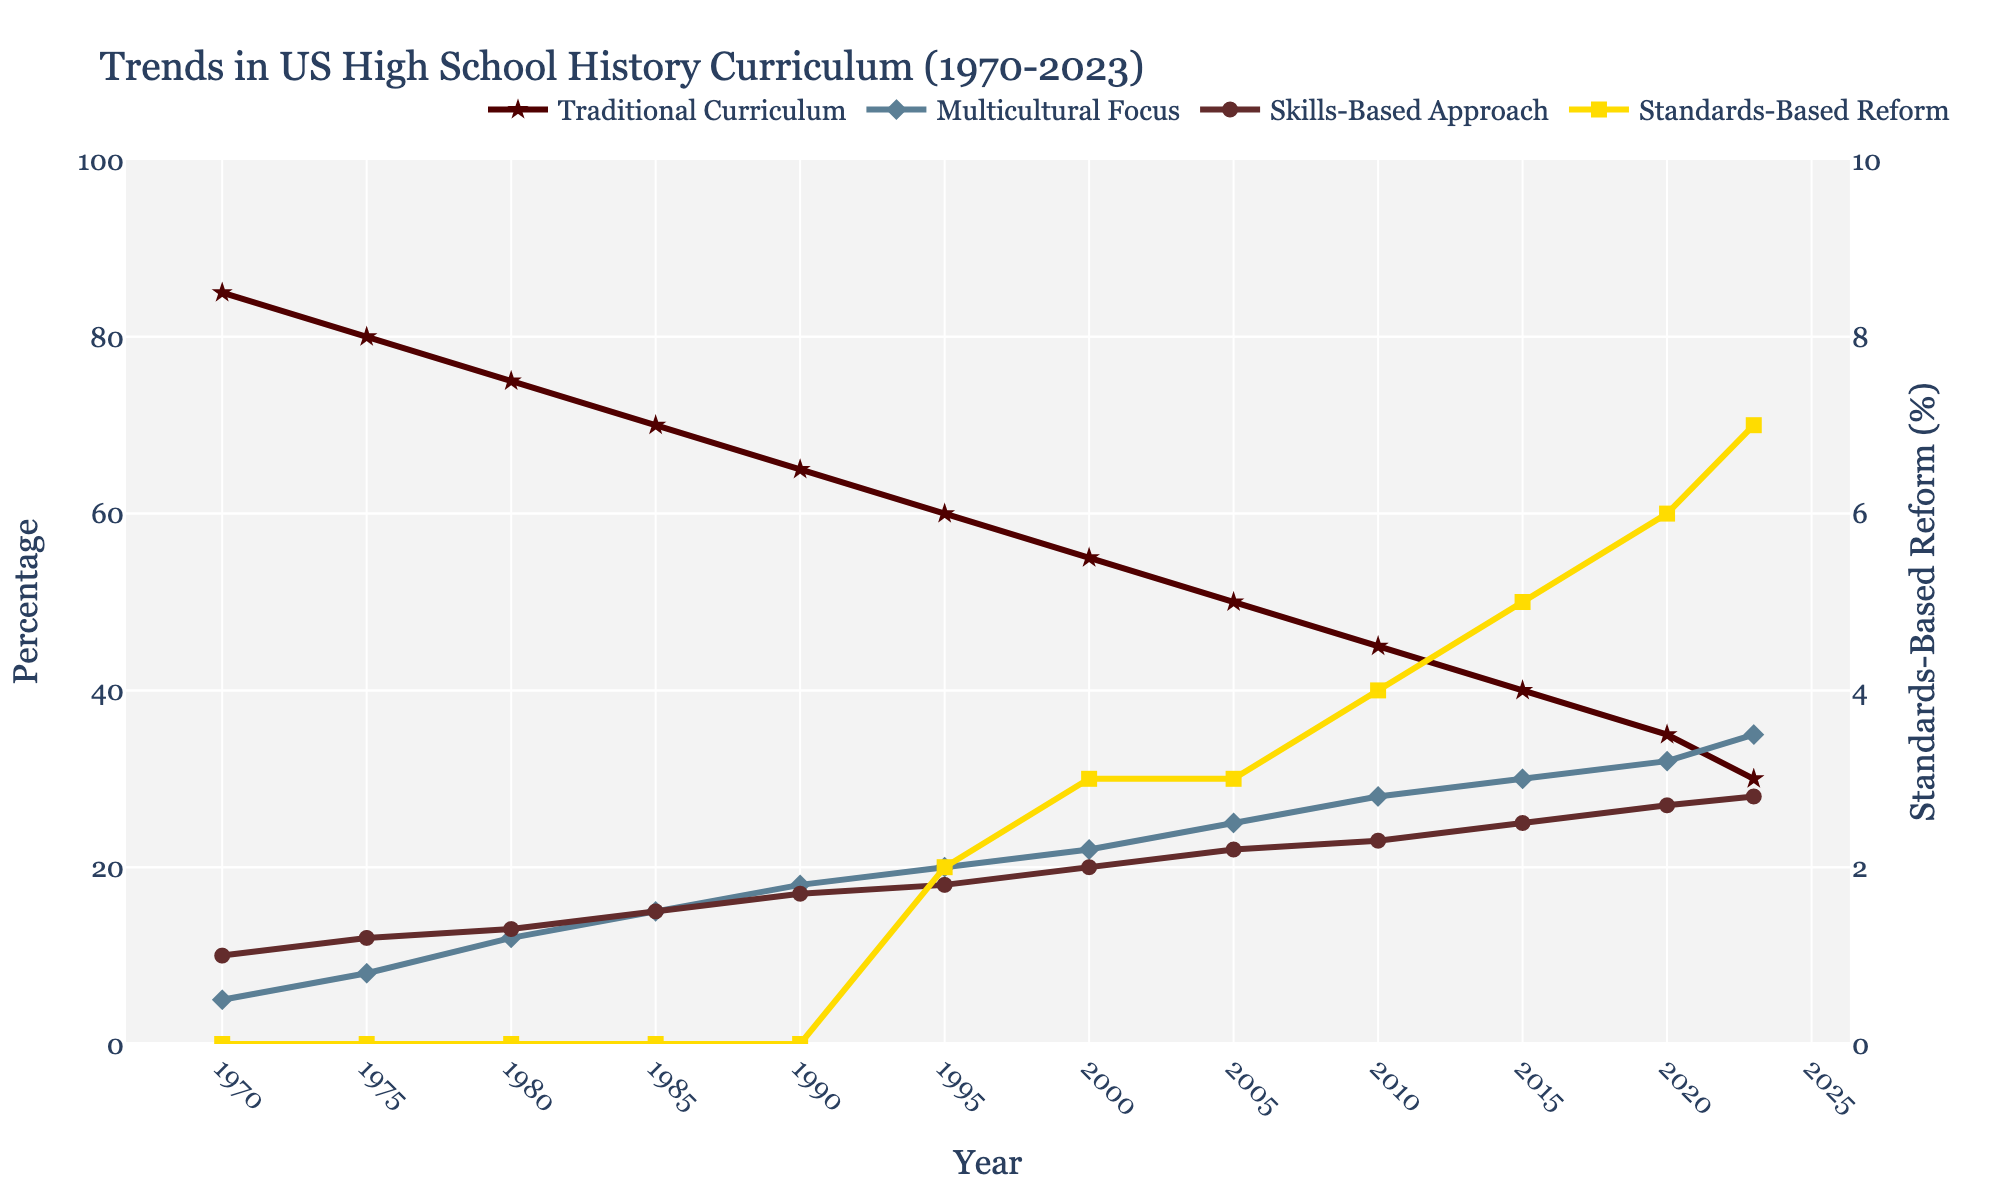Which curriculum focus remained the highest from 1970 to 2023? By observing the trend lines over the years, it's evident that the Traditional Curriculum (%), represented by the red line, remained the highest throughout the period from 1970 to 2023, despite its decline.
Answer: Traditional Curriculum What is the difference in percentage between Traditional Curriculum and Multicultural Focus in 2000? In 2000, Traditional Curriculum stands at 55%, while Multicultural Focus is at 22%. The difference is 55% - 22% = 33%.
Answer: 33% Which focus saw the most significant increase between 1970 and 2023? From 1970 to 2023, Multicultural Focus (%) grew from 5% to 35%, which is an increase of 30 percentage points. This is the highest increase among all the focuses presented.
Answer: Multicultural Focus During what period did the Traditional Curriculum experience the most substantial decline? The period from 1970 to 1990 shows a more significant decline compared to other 20-year spans, dropping by 85% - 65% = 20%.
Answer: 1970 to 1990 How did the Standards-Based Reform change from 2000 to 2023? From 2000 to 2023, Standards-Based Reform values increased from 3% to 7%. This shows a net increase of 7% - 3% = 4%.
Answer: Increased by 4% Which curriculum focus had the least change over the entire period? By comparing the changes, the Skills-Based Approach had the least overall change, increasing from 10% in 1970 to 28% in 2023, a difference of 18 percentage points.
Answer: Skills-Based Approach What was the percentage of Multicultural Focus in 2010, and how did it compare to Traditional Curriculum at that time? In 2010, Multicultural Focus was at 28%, while Traditional Curriculum was at 45%. Comparing these values show that Multicultural Focus was 17% less than Traditional Curriculum (45% - 28%).
Answer: 28%, 17% less What are the three major periods of noticeable trends in the chart? The noticeable periods based on trends are: 1970-1990 (decline in Traditional Curriculum), 1995-2010 (growth in Multicultural Focus), and 2000-2023 (steady increase in Standards-Based Reform). Each period shows significant shifts in the respective focuses.
Answer: 1970-1990, 1995-2010, 2000-2023 